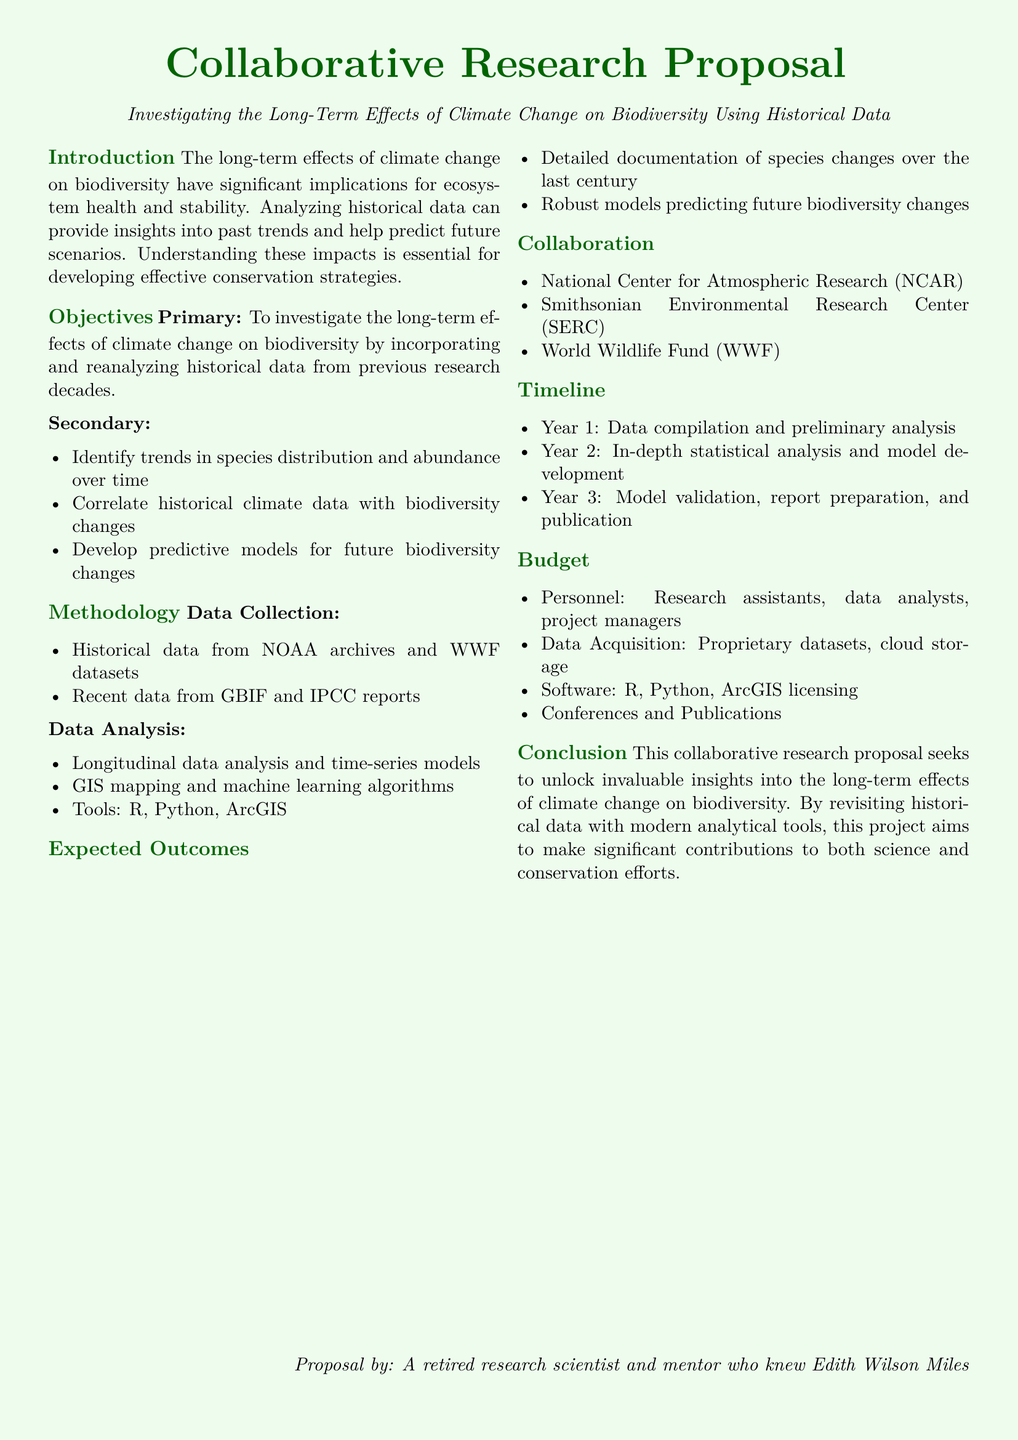What is the main focus of the research proposal? The main focus of the research proposal is to investigate the long-term effects of climate change on biodiversity using historical data.
Answer: Investigating the Long-Term Effects of Climate Change on Biodiversity What are the two types of objectives mentioned? The objectives are categorized into primary and secondary objectives, detailing their specific aims.
Answer: Primary and Secondary Who are three collaborating organizations listed in the proposal? The document specifies three organizations that will collaborate on the research proposal.
Answer: National Center for Atmospheric Research, Smithsonian Environmental Research Center, World Wildlife Fund What year is designated for in-depth statistical analysis and model development? The proposal outlines a timeline for the project, indicating specific years for certain tasks.
Answer: Year 2 Which tools are mentioned for data analysis? The proposal lists specific tools that will be utilized for data analysis as part of the methodology.
Answer: R, Python, ArcGIS What type of analysis will be conducted on historical data? The document describes a particular analysis approach that will be used on historical data within the methodology section.
Answer: Longitudinal data analysis and time-series models What is one expected outcome of the research? The expected outcomes highlight what the research aims to achieve by the end of the project.
Answer: Detailed documentation of species changes over the last century What does the budget cover? The budget section outlines various expenses related to the project, specifying key areas it will fund.
Answer: Personnel, Data Acquisition, Software, Conferences and Publications What duration is indicated for the entire project? The timeline section details how long the research project will last, estimating a specific number of years for completion.
Answer: Three years 